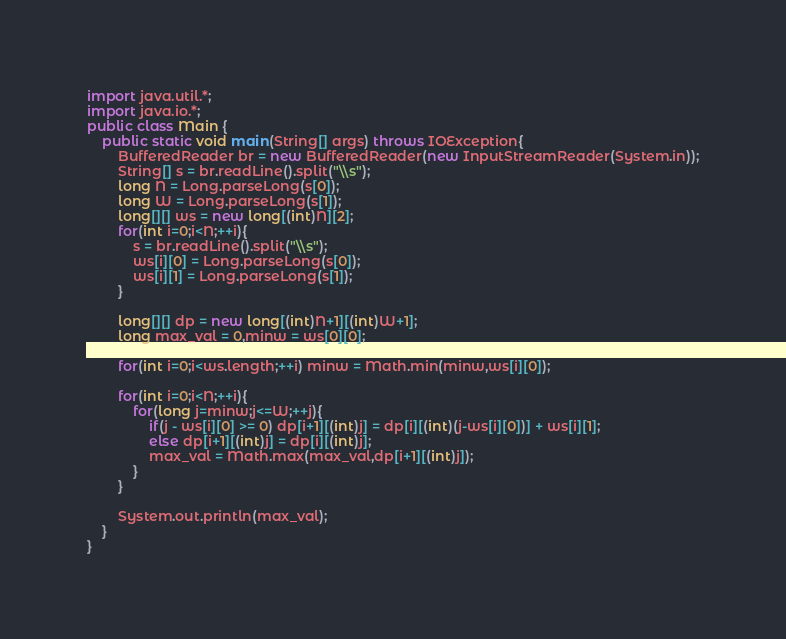Convert code to text. <code><loc_0><loc_0><loc_500><loc_500><_Java_>import java.util.*;
import java.io.*;
public class Main {
    public static void main(String[] args) throws IOException{
        BufferedReader br = new BufferedReader(new InputStreamReader(System.in));
        String[] s = br.readLine().split("\\s");
        long N = Long.parseLong(s[0]);
        long W = Long.parseLong(s[1]);
        long[][] ws = new long[(int)N][2];
        for(int i=0;i<N;++i){
            s = br.readLine().split("\\s");
            ws[i][0] = Long.parseLong(s[0]);
            ws[i][1] = Long.parseLong(s[1]);
        }
        
        long[][] dp = new long[(int)N+1][(int)W+1];
        long max_val = 0,minw = ws[0][0];
        
        for(int i=0;i<ws.length;++i) minw = Math.min(minw,ws[i][0]);
        
        for(int i=0;i<N;++i){
            for(long j=minw;j<=W;++j){
                if(j - ws[i][0] >= 0) dp[i+1][(int)j] = dp[i][(int)(j-ws[i][0])] + ws[i][1];
                else dp[i+1][(int)j] = dp[i][(int)j];
                max_val = Math.max(max_val,dp[i+1][(int)j]);
            }
        }
        
        System.out.println(max_val);
    }    
}
</code> 